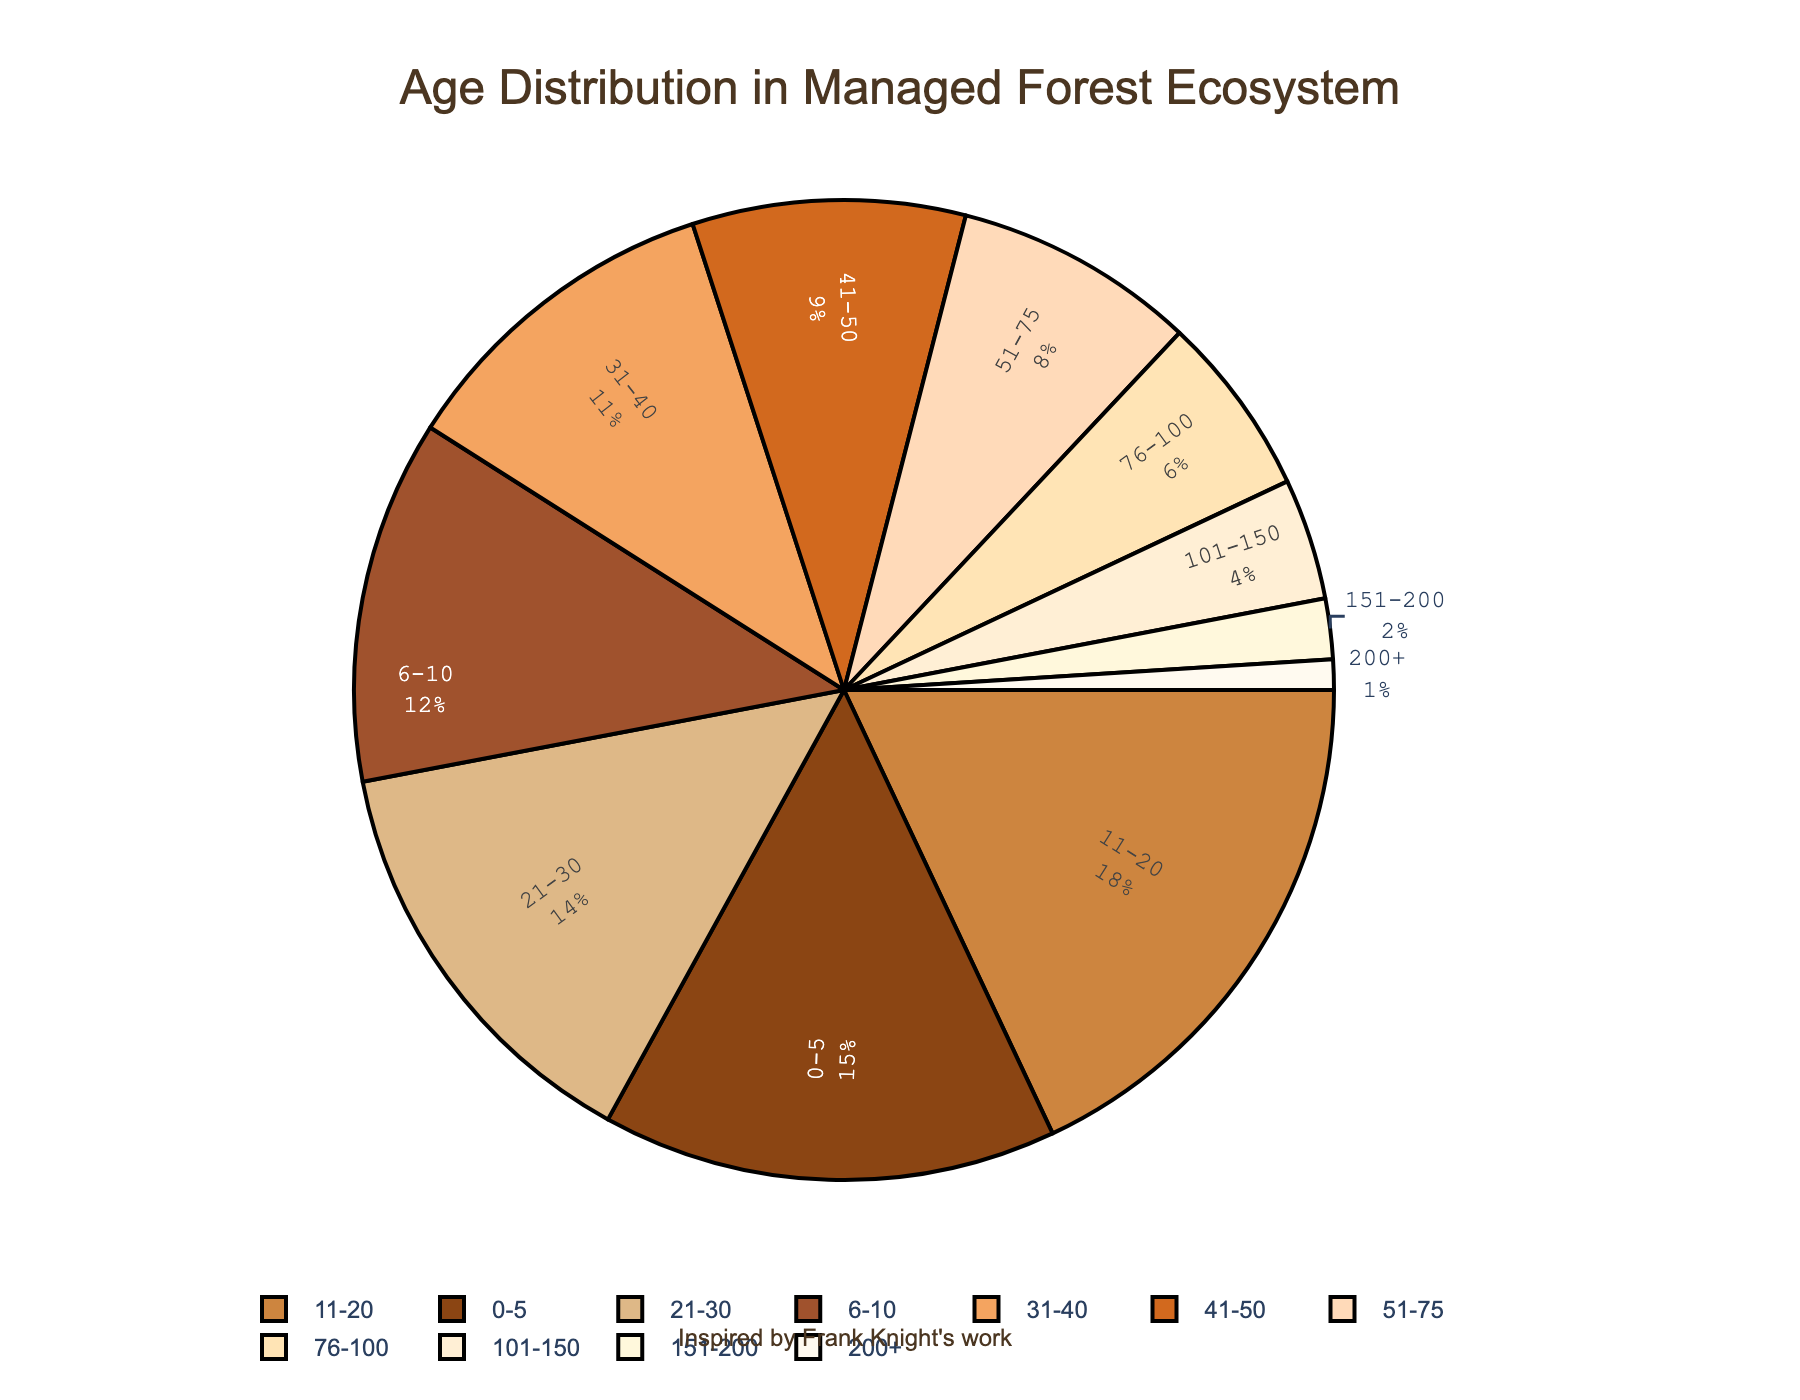What age range has the highest percentage? Look at the pie chart and identify the slice with the largest area. The label for this slice is "11-20" years.
Answer: 11-20 years Which age range has the smallest percentage? Look at the pie chart and identify the smallest slice. The label for this slice is "200+" years.
Answer: 200+ years How much greater is the percentage of trees aged 11-20 years than those aged 0-5 years? The percentage for age 11-20 years is 18%, and for 0-5 years it’s 15%. Subtract 15 from 18 to get the difference.
Answer: 3% What is the combined percentage of trees aged between 0-5 years and 6-10 years? The percentage for age 0-5 years is 15%, and for 6-10 years it’s 12%. Add them together: 15 + 12.
Answer: 27% Which age range has a higher percentage: 31-40 years or 76-100 years? Compare the percentages for age 31-40 years (11%) and 76-100 years (6%).
Answer: 31-40 years How many different age ranges have a percentage of 10% or more? Count the slices in the pie chart with percentages labeled as 10% or more: 0-5, 6-10, 11-20, and 21-30.
Answer: 4 What is the total percentage for age ranges 101-150 years and 151-200 years combined? The percentage for age 101-150 years is 4%, and for 151-200 years it’s 2%. Add them together: 4 + 2.
Answer: 6% Compare the combined percentage of trees aged 41-50 years and 51-75 years to those aged 21-30 years. Which is greater? Add the percentages for ages 41-50 years (9%) and 51-75 years (8%) to get 17%. Compare this to the percentage for ages 21-30 years (14%).
Answer: 41-50 and 51-75 years Which age range has a color closest to the shade of brown? Look at the colors of the pie chart. The lightest shade of brown typically corresponds to the range 0-5 years, as it’s a common color preference to indicate youth.
Answer: 0-5 years How does the area indicated for age range 51-75 years compare to that of 76-100 years? Compare the size of the two slices visually. The slice for 51-75 years is larger than the slice for 76-100 years.
Answer: Larger 